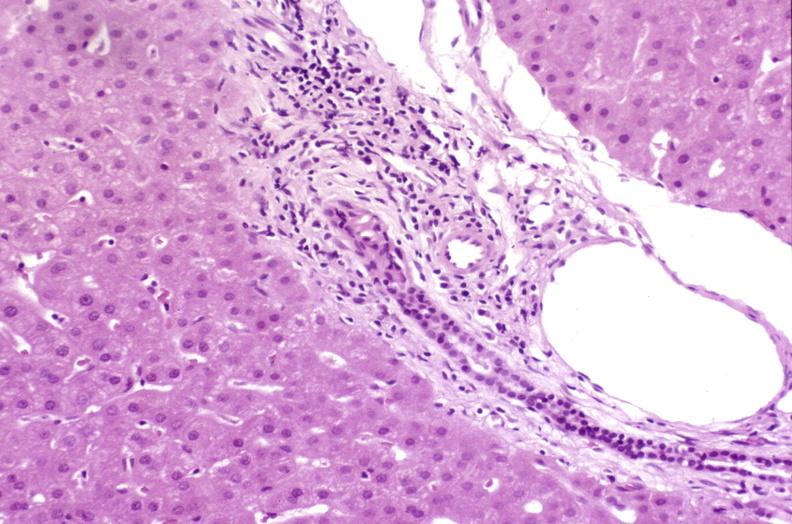s malignant thymoma present?
Answer the question using a single word or phrase. No 